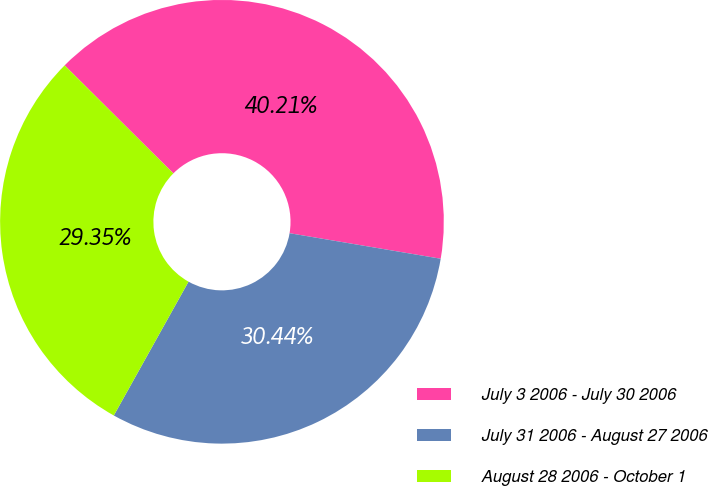Convert chart to OTSL. <chart><loc_0><loc_0><loc_500><loc_500><pie_chart><fcel>July 3 2006 - July 30 2006<fcel>July 31 2006 - August 27 2006<fcel>August 28 2006 - October 1<nl><fcel>40.21%<fcel>30.44%<fcel>29.35%<nl></chart> 